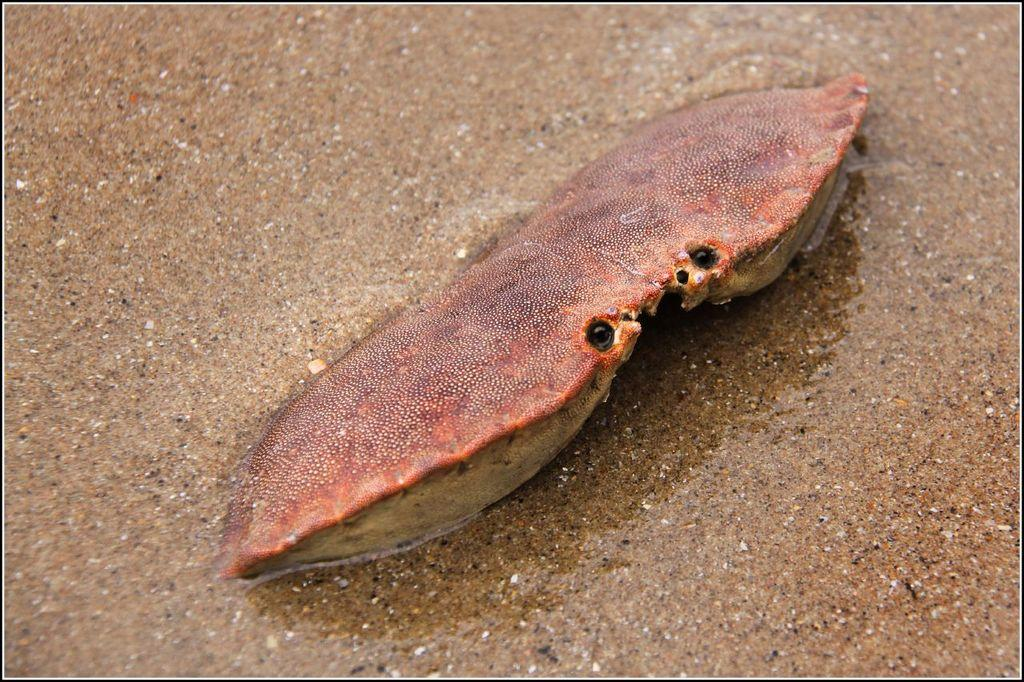What type of creature is in the image? There is a marine animal in the image. What color is the marine animal? The marine animal is brown in color. What type of surface can be seen at the bottom of the image? There is sand visible at the bottom of the image. What role does the actor play in the image? There is no actor present in the image, as it features a marine animal and sand. What type of container is used to hold the pot in the image? There is no pot present in the image, only a marine animal and sand. 